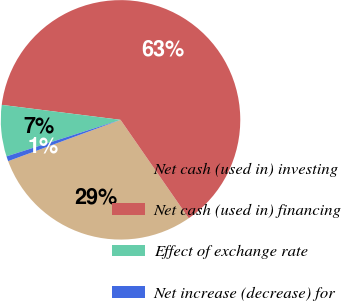<chart> <loc_0><loc_0><loc_500><loc_500><pie_chart><fcel>Net cash (used in) investing<fcel>Net cash (used in) financing<fcel>Effect of exchange rate<fcel>Net increase (decrease) for<nl><fcel>29.04%<fcel>63.36%<fcel>6.93%<fcel>0.67%<nl></chart> 